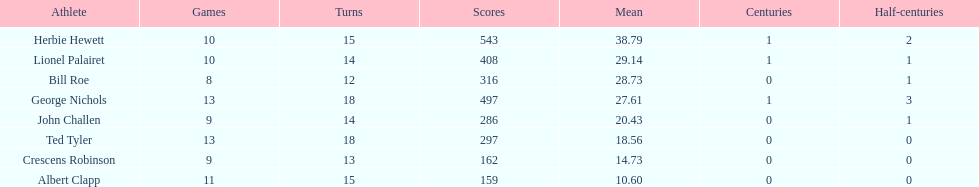How many more runs does john have than albert? 127. Write the full table. {'header': ['Athlete', 'Games', 'Turns', 'Scores', 'Mean', 'Centuries', 'Half-centuries'], 'rows': [['Herbie Hewett', '10', '15', '543', '38.79', '1', '2'], ['Lionel Palairet', '10', '14', '408', '29.14', '1', '1'], ['Bill Roe', '8', '12', '316', '28.73', '0', '1'], ['George Nichols', '13', '18', '497', '27.61', '1', '3'], ['John Challen', '9', '14', '286', '20.43', '0', '1'], ['Ted Tyler', '13', '18', '297', '18.56', '0', '0'], ['Crescens Robinson', '9', '13', '162', '14.73', '0', '0'], ['Albert Clapp', '11', '15', '159', '10.60', '0', '0']]} 